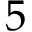Convert formula to latex. <formula><loc_0><loc_0><loc_500><loc_500>5</formula> 